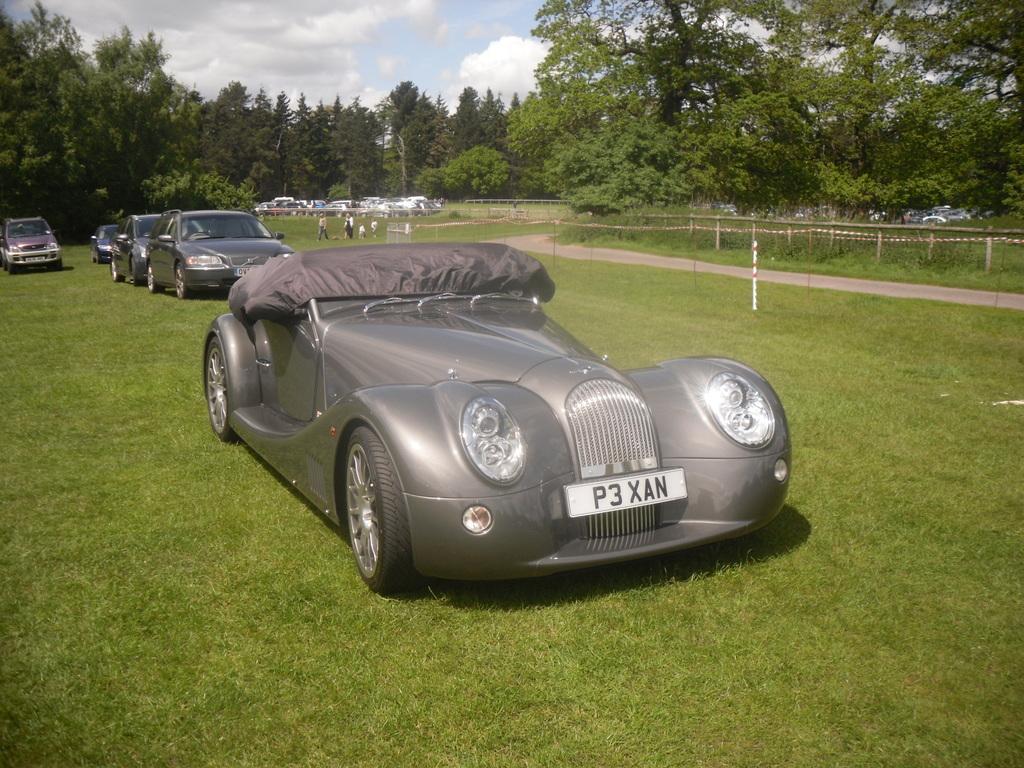How would you summarize this image in a sentence or two? In this image I can see cars visible on the ground and I can see a fence and trees in the middle and at the top I can see the sky. 